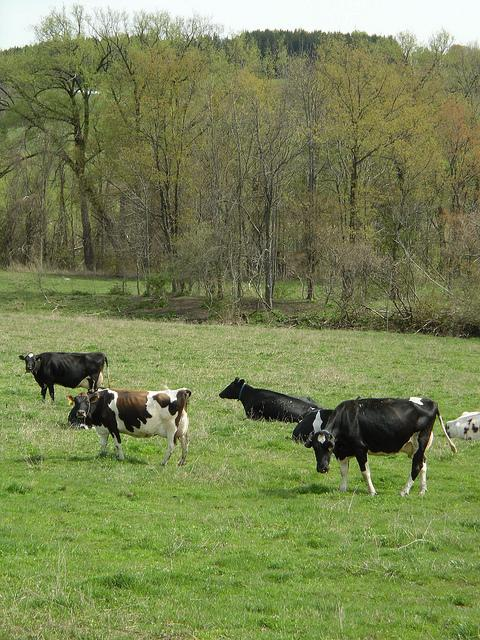What color is the strange cow just ahead to the left? brown 